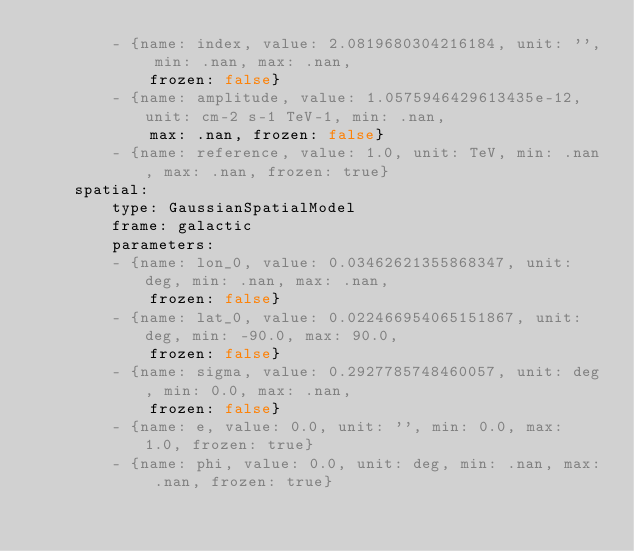<code> <loc_0><loc_0><loc_500><loc_500><_YAML_>        - {name: index, value: 2.0819680304216184, unit: '', min: .nan, max: .nan,
            frozen: false}
        - {name: amplitude, value: 1.0575946429613435e-12, unit: cm-2 s-1 TeV-1, min: .nan,
            max: .nan, frozen: false}
        - {name: reference, value: 1.0, unit: TeV, min: .nan, max: .nan, frozen: true}
    spatial:
        type: GaussianSpatialModel
        frame: galactic
        parameters:
        - {name: lon_0, value: 0.03462621355868347, unit: deg, min: .nan, max: .nan,
            frozen: false}
        - {name: lat_0, value: 0.022466954065151867, unit: deg, min: -90.0, max: 90.0,
            frozen: false}
        - {name: sigma, value: 0.2927785748460057, unit: deg, min: 0.0, max: .nan,
            frozen: false}
        - {name: e, value: 0.0, unit: '', min: 0.0, max: 1.0, frozen: true}
        - {name: phi, value: 0.0, unit: deg, min: .nan, max: .nan, frozen: true}
</code> 